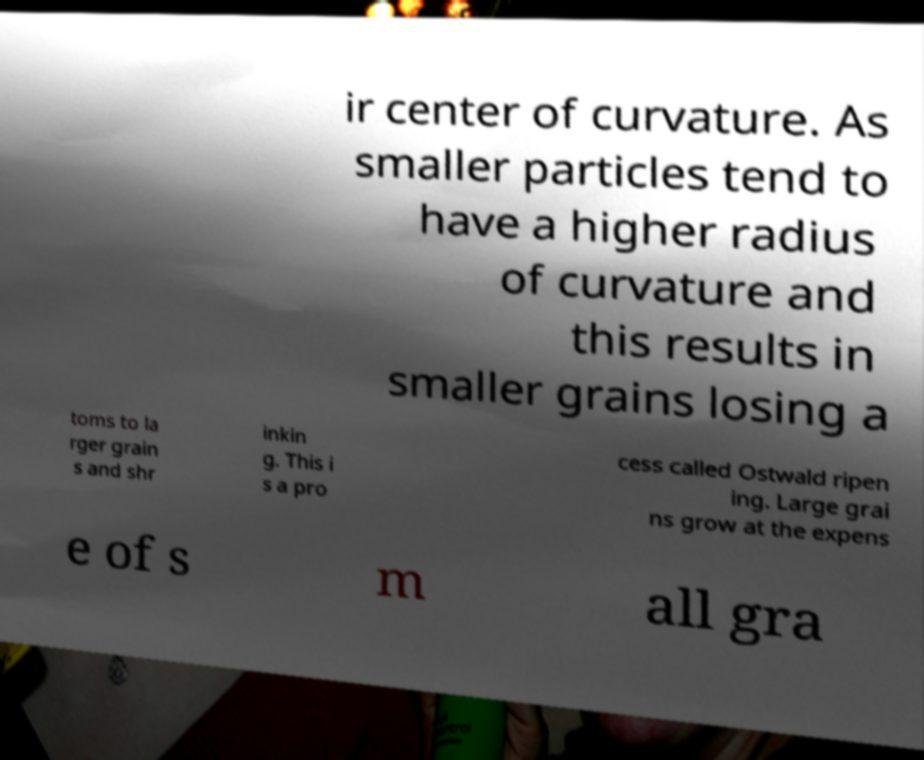What messages or text are displayed in this image? I need them in a readable, typed format. ir center of curvature. As smaller particles tend to have a higher radius of curvature and this results in smaller grains losing a toms to la rger grain s and shr inkin g. This i s a pro cess called Ostwald ripen ing. Large grai ns grow at the expens e of s m all gra 